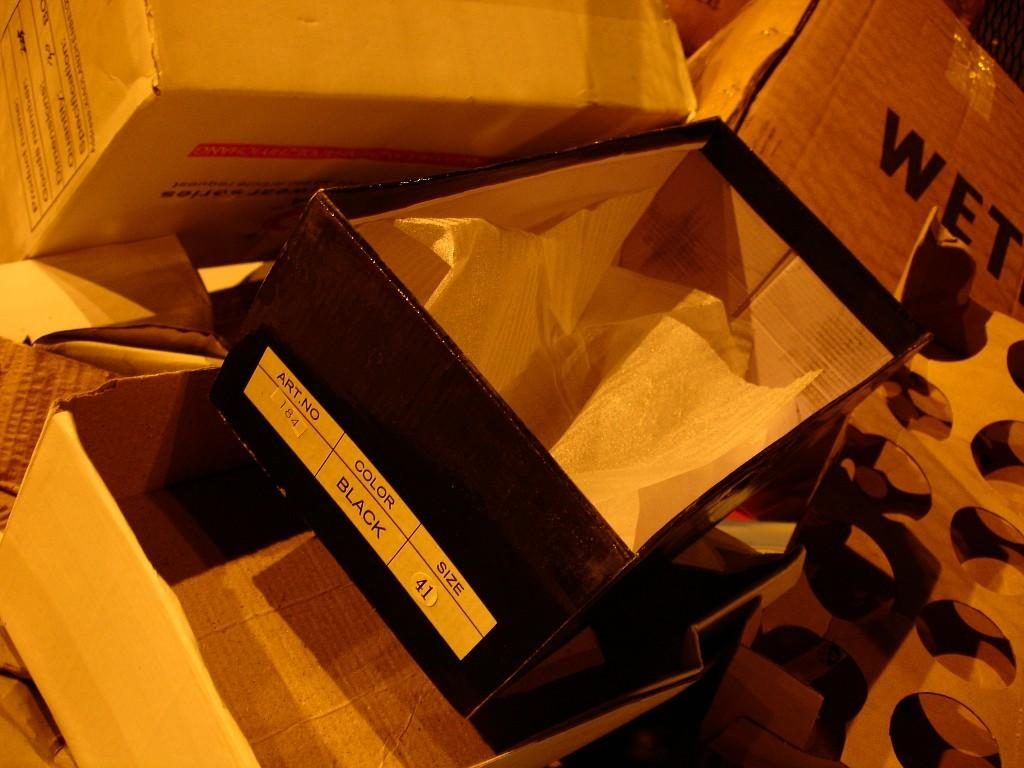Provide a one-sentence caption for the provided image. Shoe box for a black shoes that was size 41. 